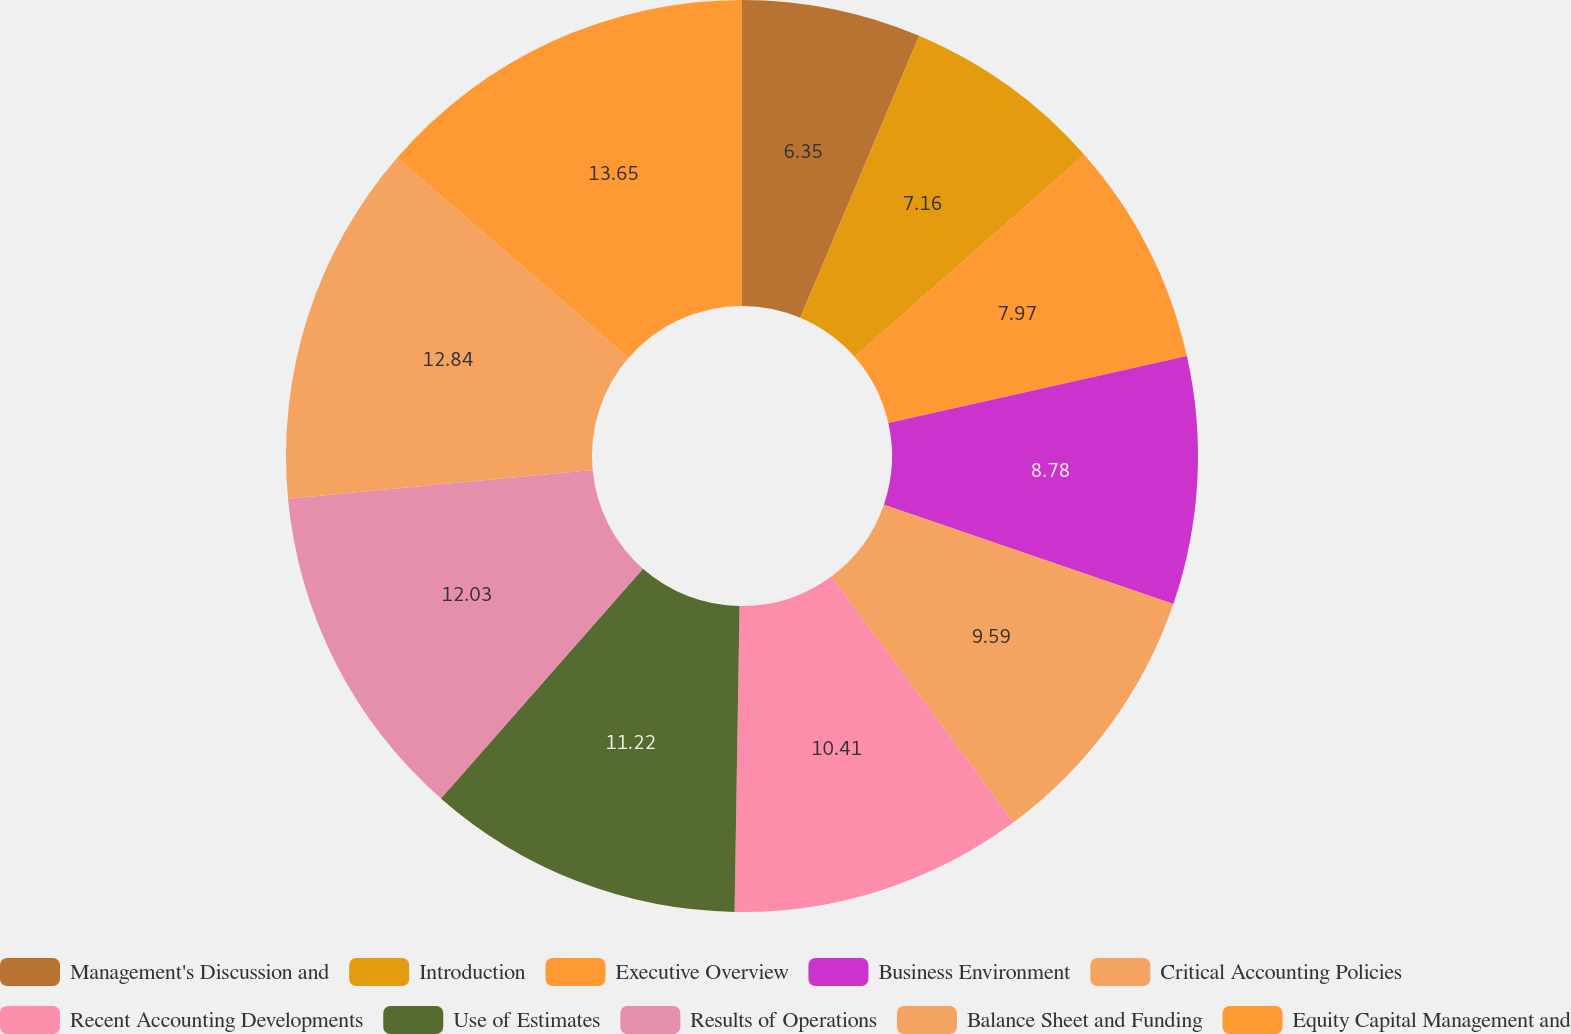Convert chart. <chart><loc_0><loc_0><loc_500><loc_500><pie_chart><fcel>Management's Discussion and<fcel>Introduction<fcel>Executive Overview<fcel>Business Environment<fcel>Critical Accounting Policies<fcel>Recent Accounting Developments<fcel>Use of Estimates<fcel>Results of Operations<fcel>Balance Sheet and Funding<fcel>Equity Capital Management and<nl><fcel>6.35%<fcel>7.16%<fcel>7.97%<fcel>8.78%<fcel>9.59%<fcel>10.41%<fcel>11.22%<fcel>12.03%<fcel>12.84%<fcel>13.65%<nl></chart> 